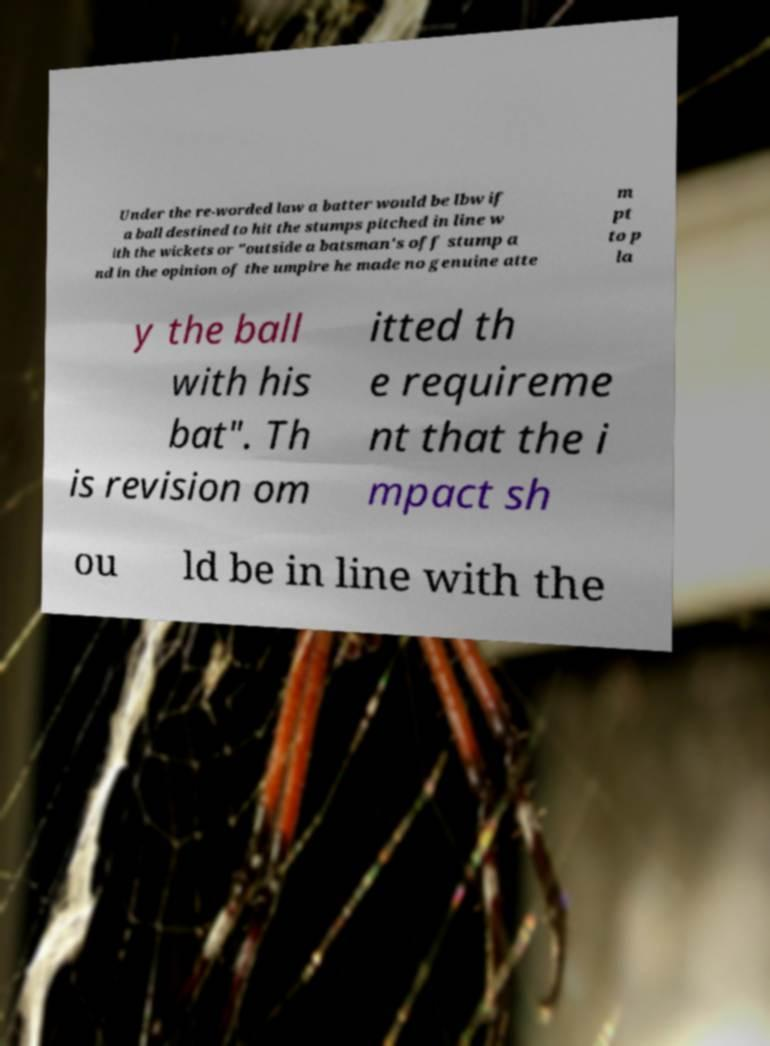Please identify and transcribe the text found in this image. Under the re-worded law a batter would be lbw if a ball destined to hit the stumps pitched in line w ith the wickets or "outside a batsman's off stump a nd in the opinion of the umpire he made no genuine atte m pt to p la y the ball with his bat". Th is revision om itted th e requireme nt that the i mpact sh ou ld be in line with the 